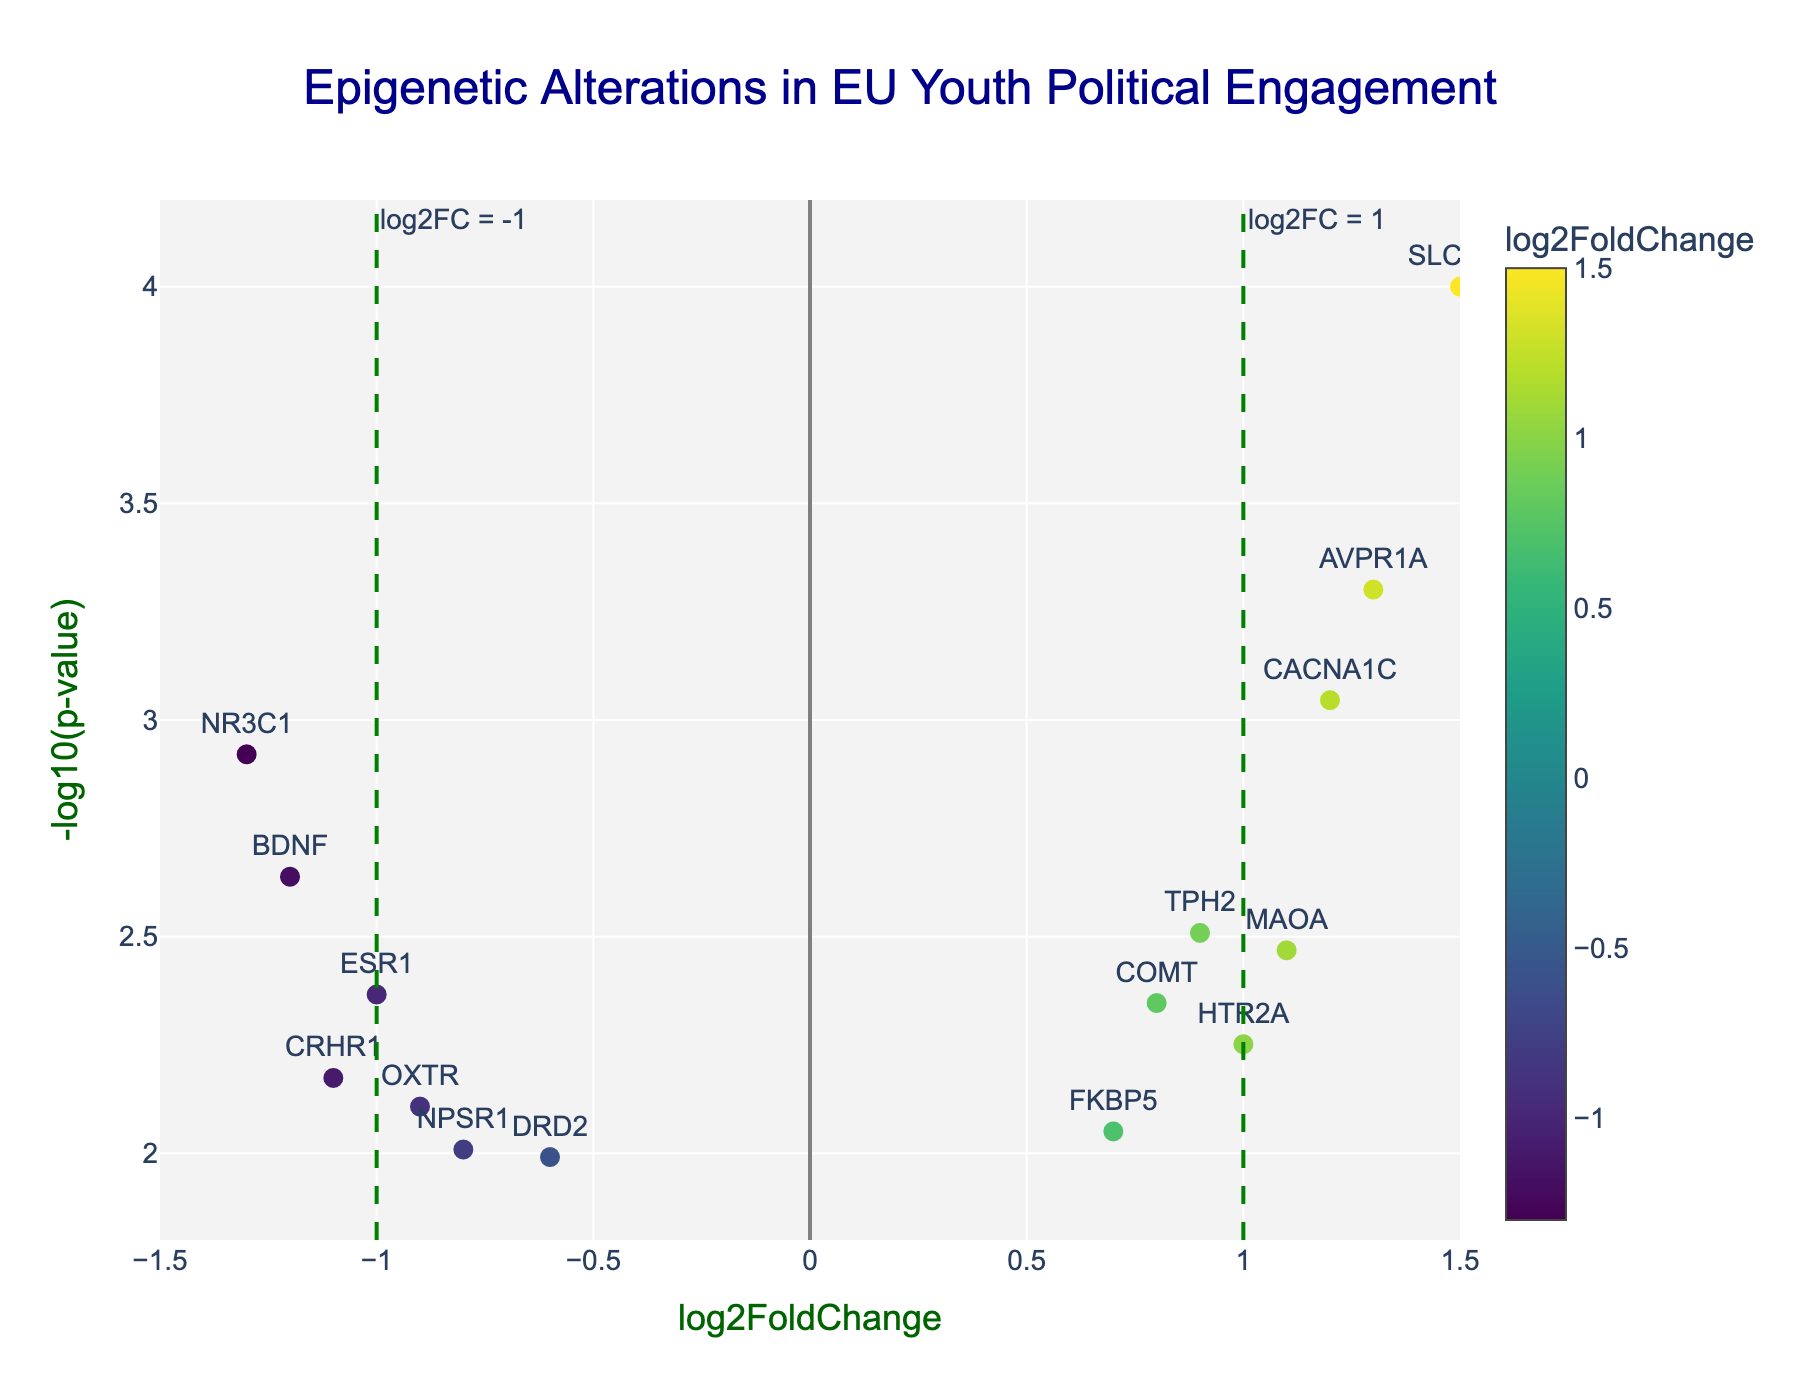What is the title of the figure? The title of the figure is typically placed at the top of the plot and is a brief description of what the plot depicts.
Answer: Epigenetic Alterations in EU Youth Political Engagement How many genes showed a log2FoldChange greater than 1? Locate the data points where the log2FoldChange is greater than 1. The genes with log2FoldChange greater than 1 are SLC6A4, CACNA1C, and AVPR1A.
Answer: 3 What gene has the highest -log10(p-value)? Find the data point that is the highest on the y-axis. SLC6A4 has the highest value since it has the lowest p-value (0.0001).
Answer: SLC6A4 Are there any genes with a log2FoldChange less than -1 and a p-value less than 0.05? Check the data points in the quadrant with log2FoldChange less than -1 and p-value below the red dashed line at 0.05. NR3C1 and BDNF both satisfy these conditions.
Answer: Yes, 2 genes (NR3C1 and BDNF) Which gene has the lowest log2FoldChange but is still considered statistically significant (p-value < 0.05)? Look for the gene with the lowest log2FoldChange that is below the red threshold line. The gene CRHR1 fits this criterion.
Answer: CRHR1 What color represents the genes with the lowest log2FoldChange values? The color scale is Viridis, where lower log2FoldChange values generally have darker colors.
Answer: Darker colors Is there any gene that exhibits both high statistical significance and large positive log2FoldChange? Look for genes above the threshold line (-log10(p-value) > 1.3) and log2FoldChange greater than 1. AVPR1A, CACNA1C, and SLC6A4 meet these criteria.
Answer: Yes, 3 genes (AVPR1A, CACNA1C, SLC6A4) What is the range of -log10(p-value) in the plot? The y-axis range can be directly read from the plot. It goes from 1.8 to 4.2.
Answer: 1.8 to 4.2 